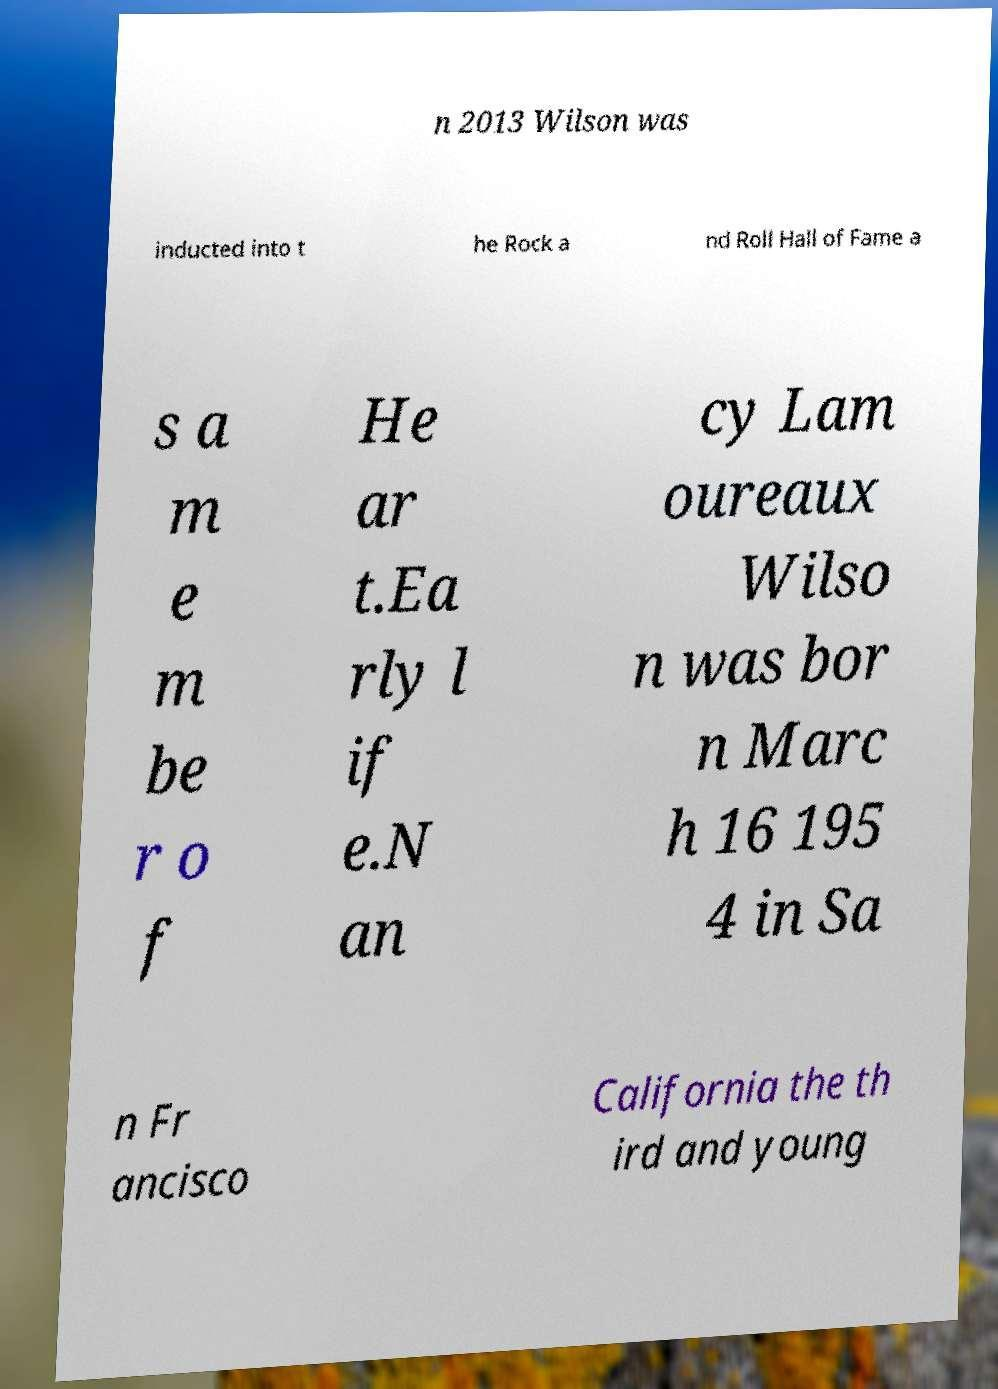Could you extract and type out the text from this image? n 2013 Wilson was inducted into t he Rock a nd Roll Hall of Fame a s a m e m be r o f He ar t.Ea rly l if e.N an cy Lam oureaux Wilso n was bor n Marc h 16 195 4 in Sa n Fr ancisco California the th ird and young 